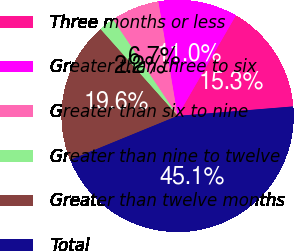<chart> <loc_0><loc_0><loc_500><loc_500><pie_chart><fcel>Three months or less<fcel>Greater than three to six<fcel>Greater than six to nine<fcel>Greater than nine to twelve<fcel>Greater than twelve months<fcel>Total<nl><fcel>15.33%<fcel>11.03%<fcel>6.74%<fcel>2.17%<fcel>19.62%<fcel>45.11%<nl></chart> 